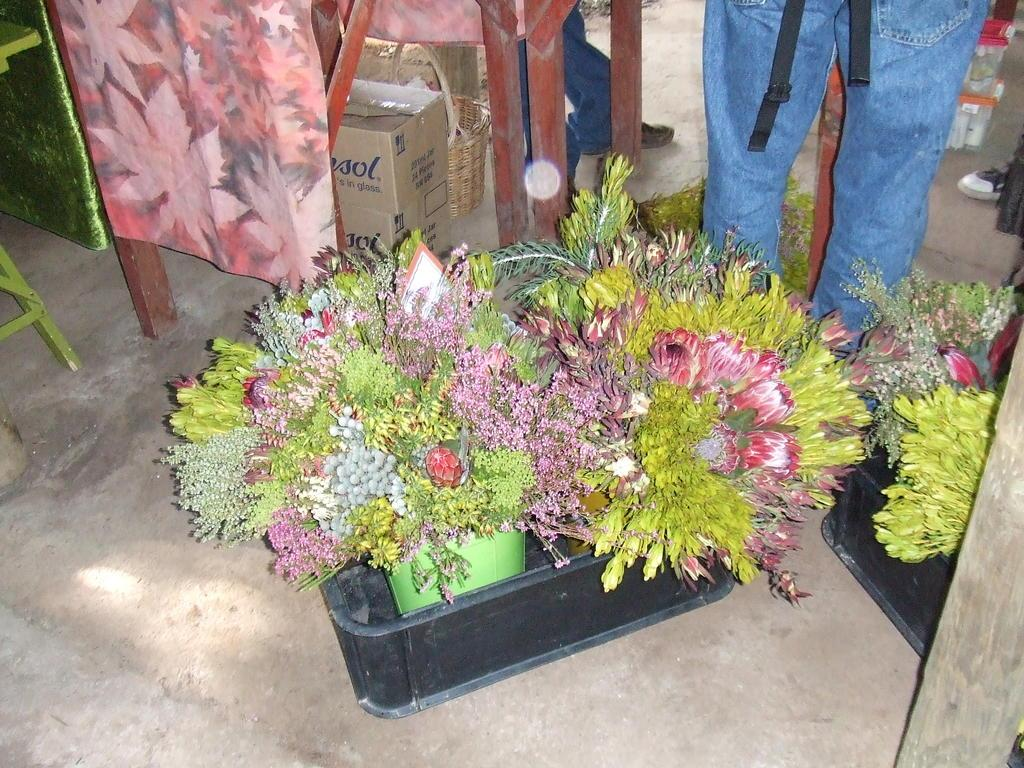What objects can be seen on the path in the image? There are flower pots on the path in the image. What container is visible in the image? There is a basket in the image. What type of storage containers are present in the image? There are boxes in the image. Can you describe the people visible in the background of the image? There are people visible in the background of the image, but their specific actions or characteristics are not mentioned in the provided facts. Where is the table located in the image? The table is on the left side of the image. What type of berry is being used as a decoration on the table in the image? There is no mention of berries being used as decoration in the image. What card game are the people playing in the background of the image? There is no indication of a card game or any game being played in the image. 